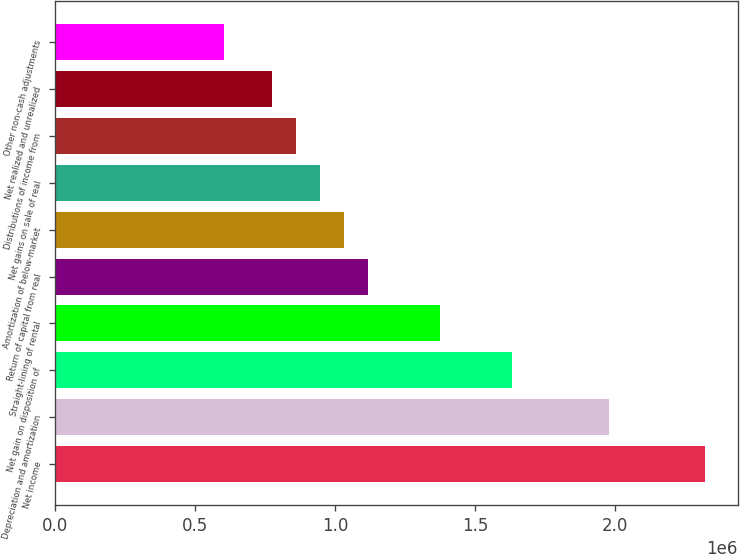<chart> <loc_0><loc_0><loc_500><loc_500><bar_chart><fcel>Net income<fcel>Depreciation and amortization<fcel>Net gain on disposition of<fcel>Straight-lining of rental<fcel>Return of capital from real<fcel>Amortization of below-market<fcel>Net gains on sale of real<fcel>Distributions of income from<fcel>Net realized and unrealized<fcel>Other non-cash adjustments<nl><fcel>2.32003e+06<fcel>1.97636e+06<fcel>1.63269e+06<fcel>1.37493e+06<fcel>1.11718e+06<fcel>1.03126e+06<fcel>945347<fcel>859430<fcel>773513<fcel>601678<nl></chart> 